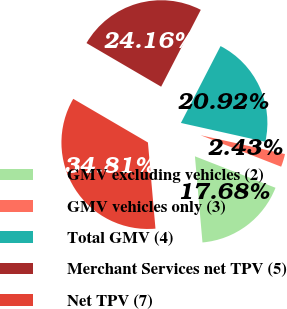Convert chart to OTSL. <chart><loc_0><loc_0><loc_500><loc_500><pie_chart><fcel>GMV excluding vehicles (2)<fcel>GMV vehicles only (3)<fcel>Total GMV (4)<fcel>Merchant Services net TPV (5)<fcel>Net TPV (7)<nl><fcel>17.68%<fcel>2.43%<fcel>20.92%<fcel>24.16%<fcel>34.81%<nl></chart> 